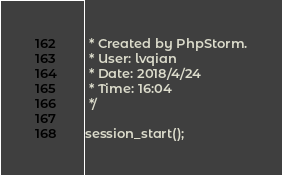<code> <loc_0><loc_0><loc_500><loc_500><_PHP_> * Created by PhpStorm.
 * User: lvqian
 * Date: 2018/4/24
 * Time: 16:04
 */

session_start();</code> 